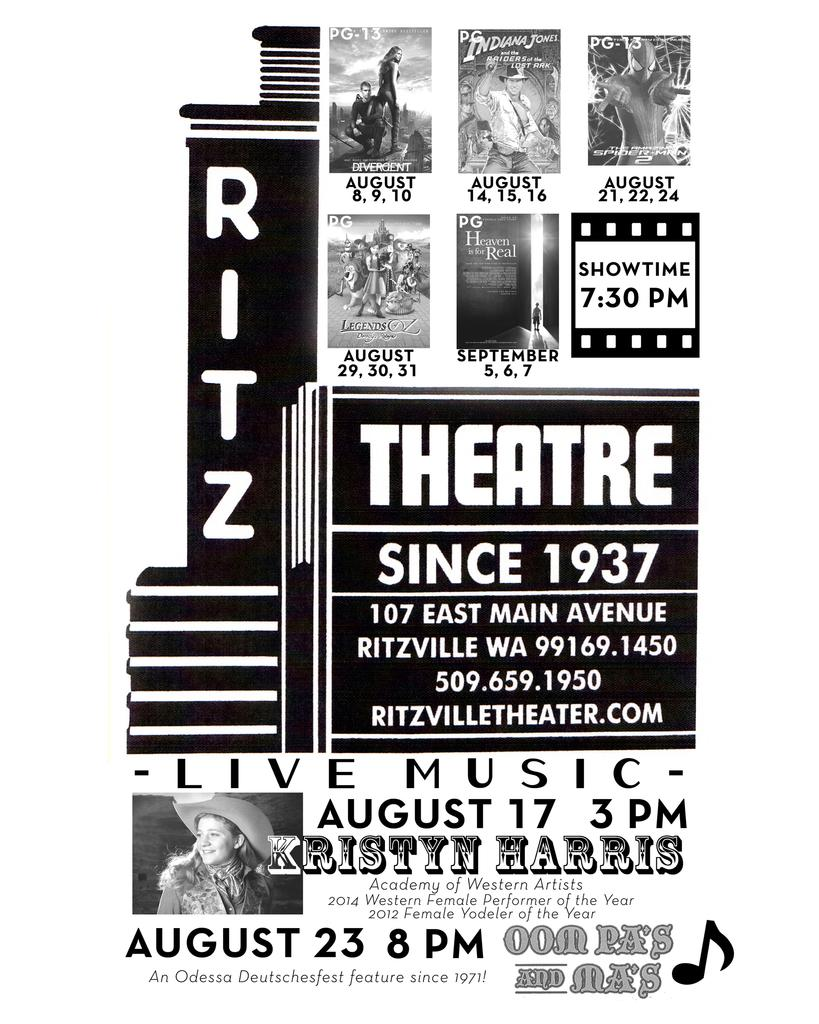<image>
Offer a succinct explanation of the picture presented. A Ritz Theatre poster announcing Live Music August 17 3 PM 